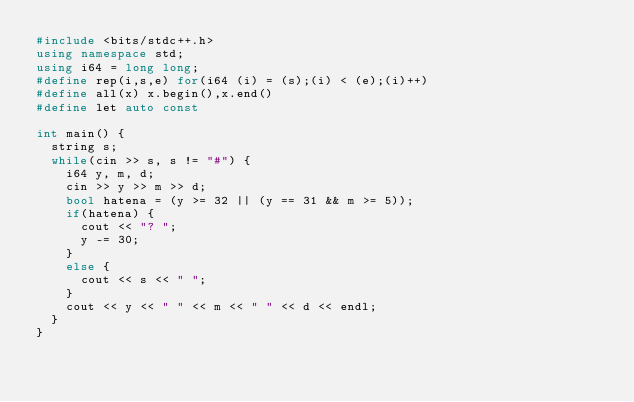<code> <loc_0><loc_0><loc_500><loc_500><_C++_>#include <bits/stdc++.h>
using namespace std;
using i64 = long long;
#define rep(i,s,e) for(i64 (i) = (s);(i) < (e);(i)++)
#define all(x) x.begin(),x.end()
#define let auto const

int main() {
  string s;
  while(cin >> s, s != "#") {
    i64 y, m, d;
    cin >> y >> m >> d;
    bool hatena = (y >= 32 || (y == 31 && m >= 5));
    if(hatena) {
      cout << "? ";
      y -= 30;
    }
    else {
      cout << s << " ";
    }
    cout << y << " " << m << " " << d << endl;
  }
}

</code> 